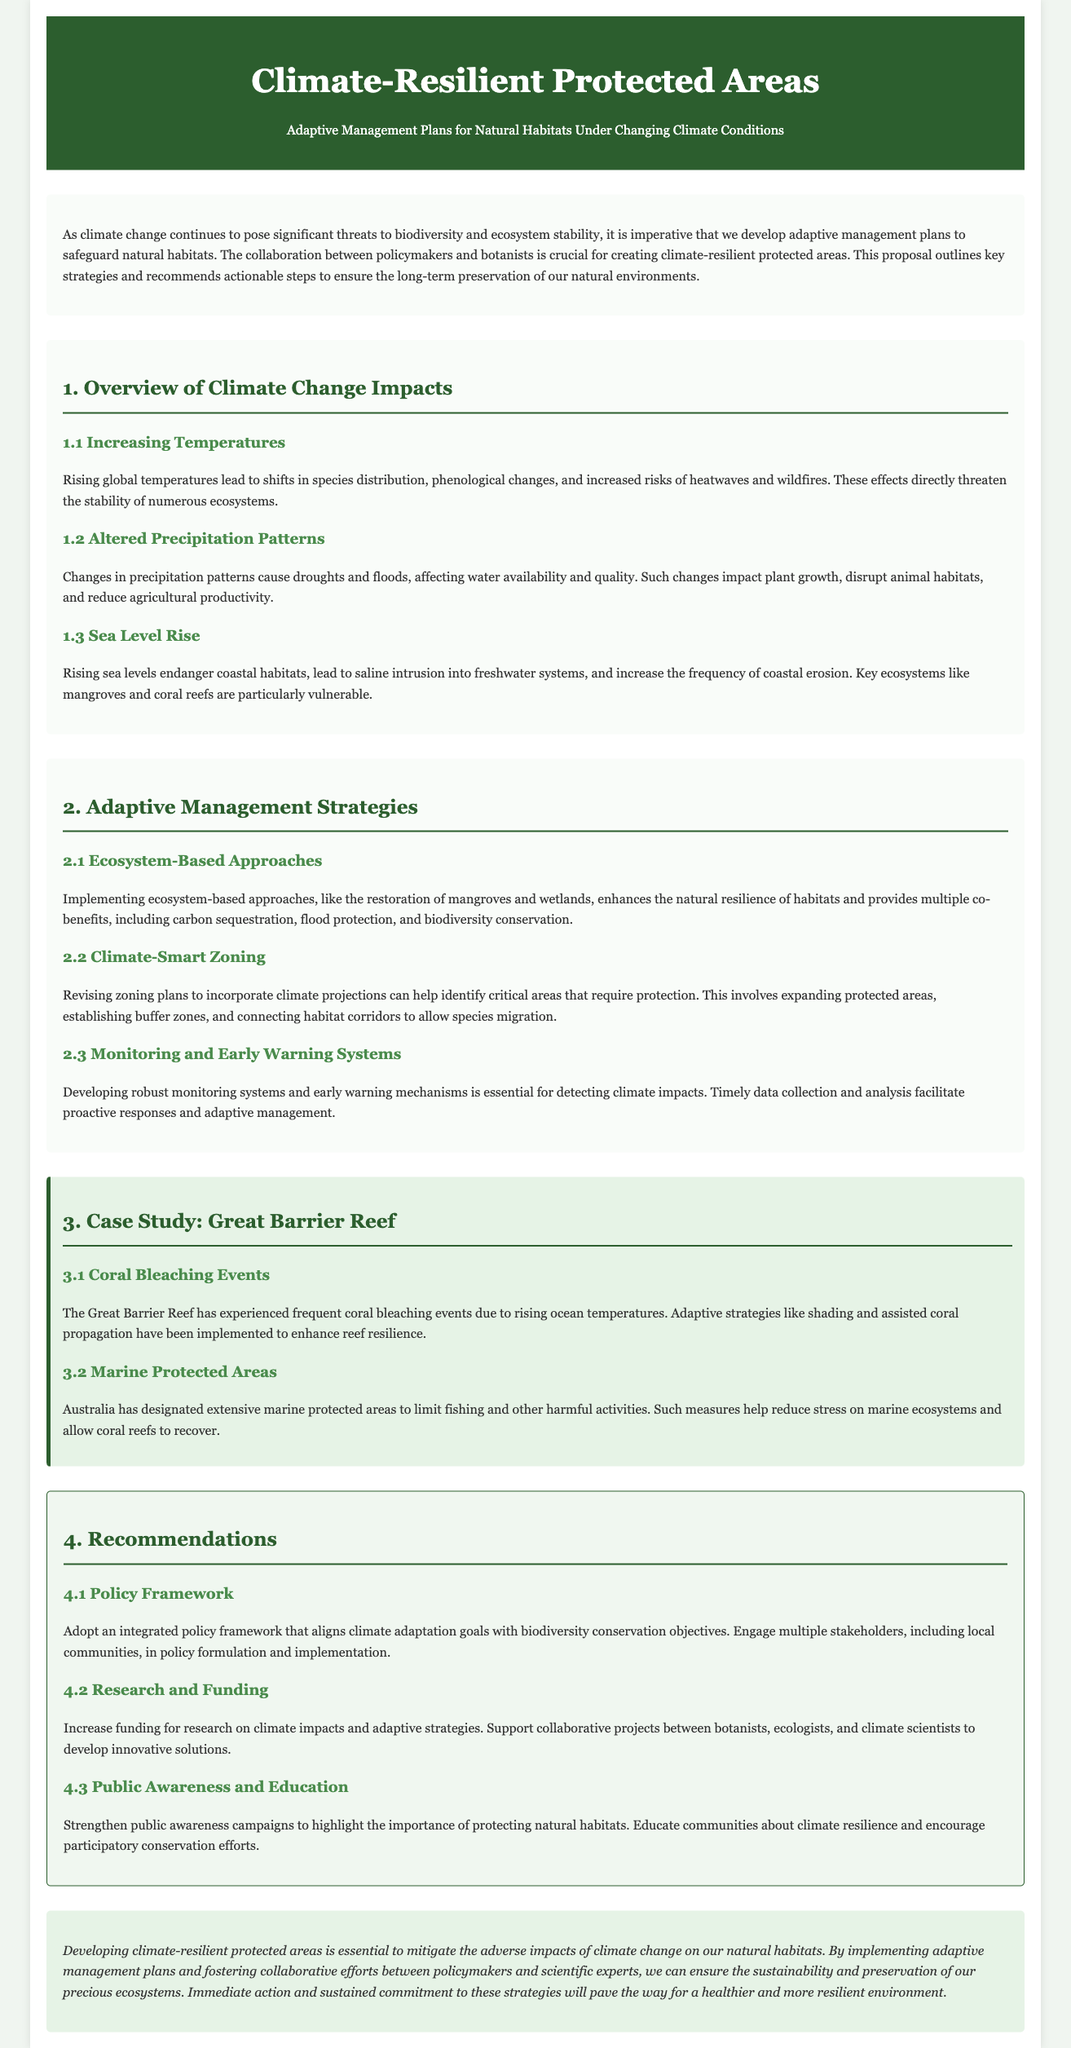What is the title of the proposal? The title of the proposal is provided in the header section of the document.
Answer: Climate-Resilient Protected Areas What is one key climate change impact mentioned? This information is found in section 1, which outlines specific impacts of climate change.
Answer: Rising global temperatures What does the case study focus on? The document indicates the specific area of study in the case study section, which highlights particular issues faced.
Answer: Great Barrier Reef What is one adaptive management strategy proposed? The document lists several strategies in section 2, which provide actionable approaches.
Answer: Ecosystem-Based Approaches What type of frameworks does the proposal recommend adopting? The recommendation section specifies the type of frameworks that are suggested for implementation.
Answer: Integrated policy framework How many sub-sections are in the overview of climate change impacts? This refers to the count of specific sections listed under the overview header in the document.
Answer: Three What is one recommendation related to public engagement? The recommendations section discusses the importance of public engagement and education on certain topics.
Answer: Public Awareness and Education 